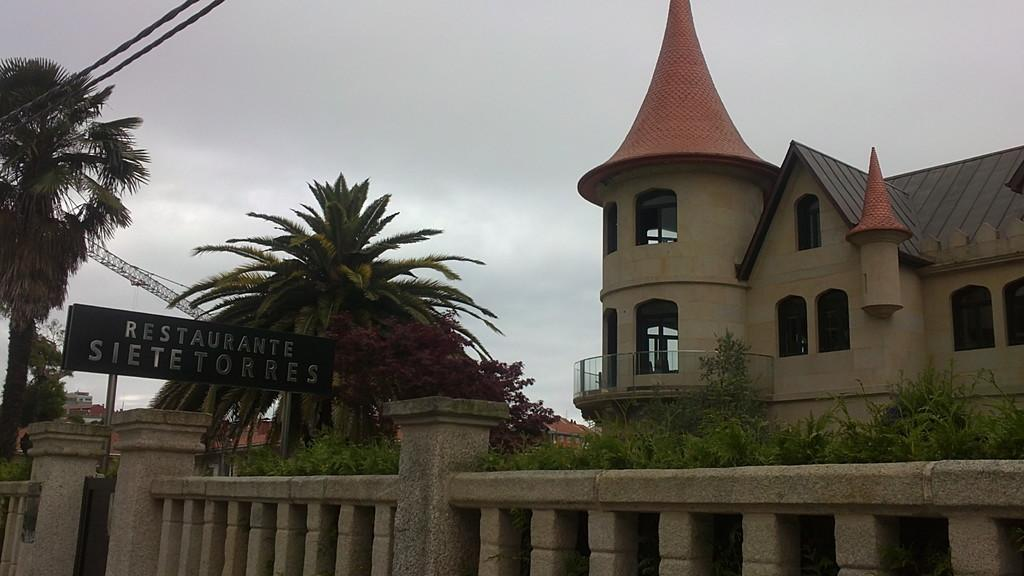What type of structures can be seen in the image? There are buildings in the image. What is located at the bottom of the image? There is a wall at the bottom of the image. What is attached to the wall? There is a board visible on the wall. What can be seen in the background of the image? There are trees, wires, and the sky visible in the background of the image. How many fish are swimming in the sky in the image? There are no fish present in the image, and the sky is not a body of water where fish would swim. 